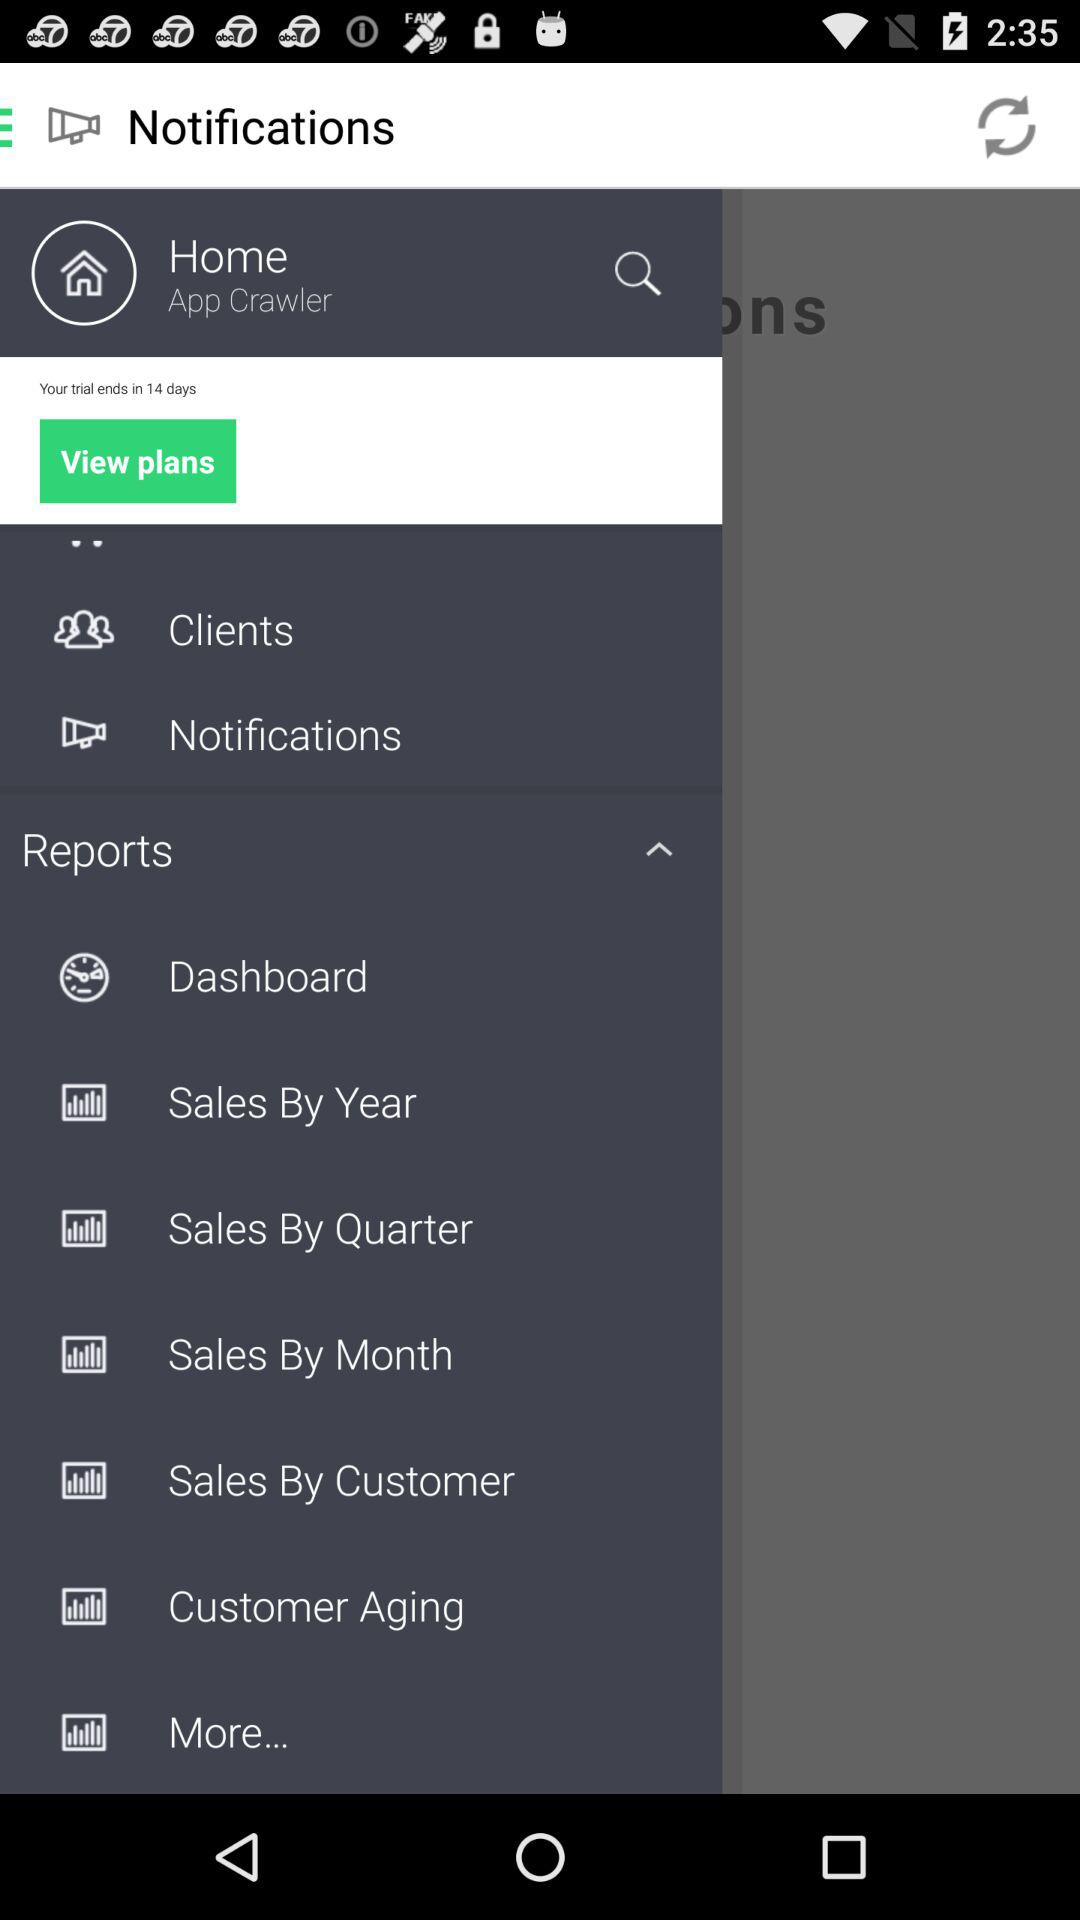What is the name of the user? The name of the user is App Crawler. 